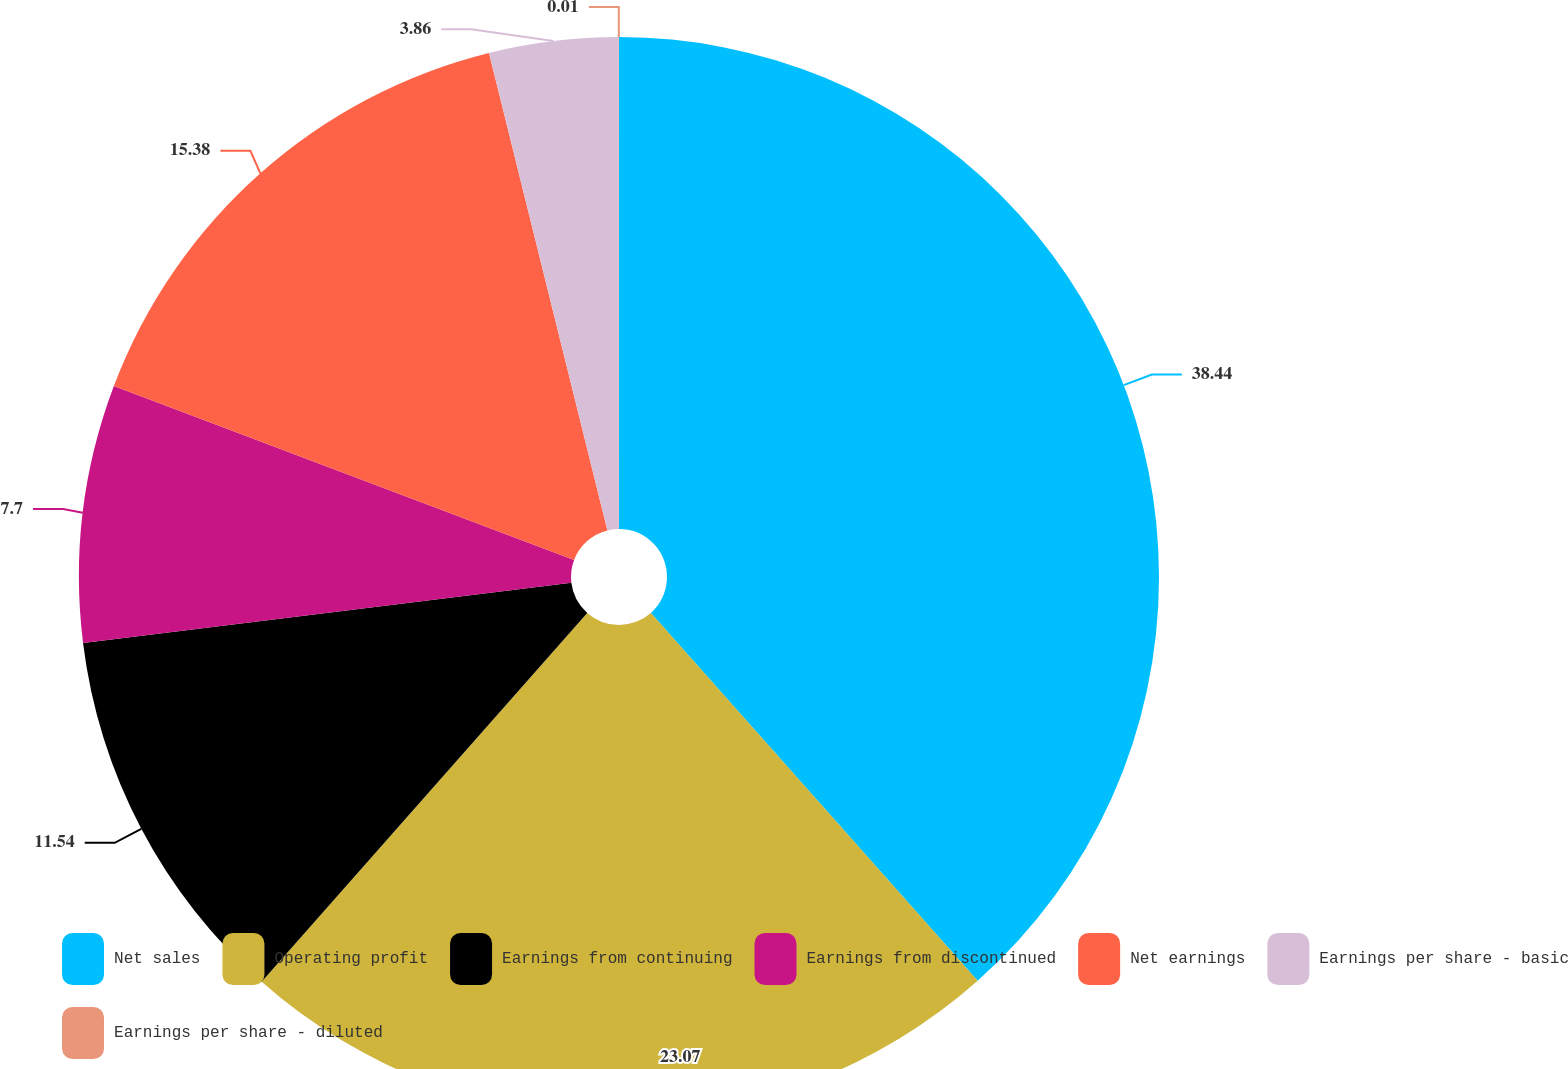Convert chart. <chart><loc_0><loc_0><loc_500><loc_500><pie_chart><fcel>Net sales<fcel>Operating profit<fcel>Earnings from continuing<fcel>Earnings from discontinued<fcel>Net earnings<fcel>Earnings per share - basic<fcel>Earnings per share - diluted<nl><fcel>38.44%<fcel>23.07%<fcel>11.54%<fcel>7.7%<fcel>15.38%<fcel>3.86%<fcel>0.01%<nl></chart> 